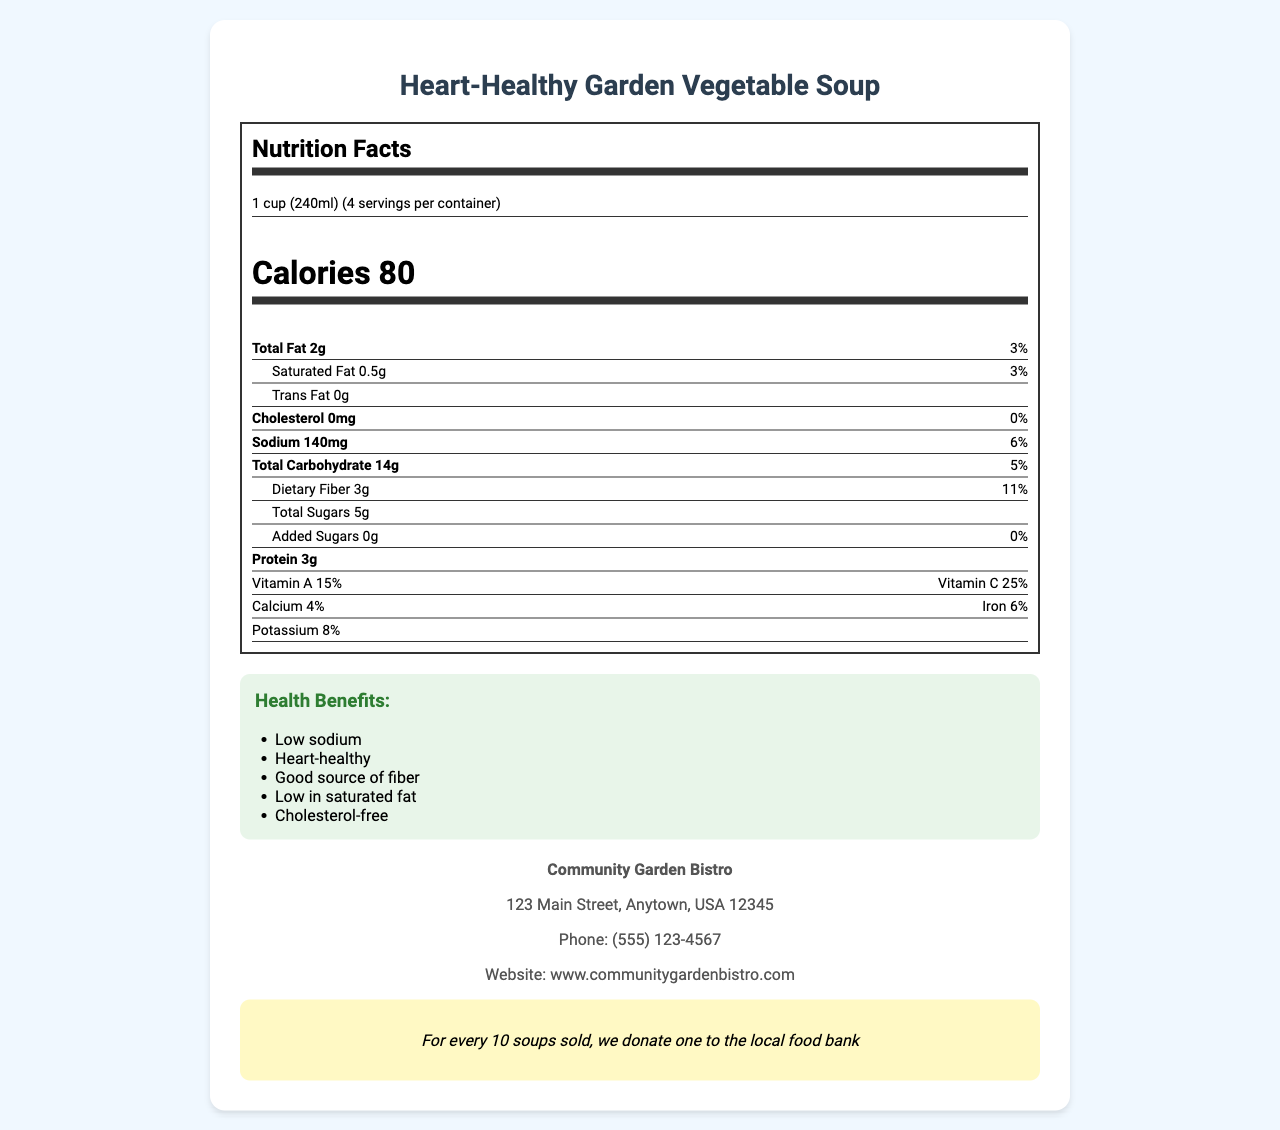What is the serving size for the Heart-Healthy Garden Vegetable Soup? The serving size is listed as "1 cup (240ml)" in the document.
Answer: 1 cup (240ml) How many calories are there per serving? The document states that there are 80 calories per serving.
Answer: 80 What percentage of the daily value of sodium does one serving contain? The sodium content per serving is listed as 6% of the daily value.
Answer: 6% List three main ingredients found in the Heart-Healthy Garden Vegetable Soup. The document lists "Vegetable broth," "Tomatoes," and "Carrots" among the ingredients.
Answer: Vegetable broth, Tomatoes, Carrots What is the preparation method mentioned for the soup? The preparation method stated in the document is "Slow-cooked to preserve nutrients."
Answer: Slow-cooked to preserve nutrients What certification does the soup have for its heart-health benefits? A. USDA Organic B. Non-GMO Project Verified C. American Heart Association Certified The document mentions that the soup is "American Heart Association Certified."
Answer: C Which of the following is a health claim made about the soup? I. Low sodium II. High protein III. Low in saturated fat The health claims listed in the document include "Low sodium" and "Low in saturated fat."
Answer: I and III Does the soup contain any allergens? The document states that there are "None" listed under allergens.
Answer: No Summarize the main idea of the document. The document provides comprehensive information on the soup's nutritional value, ingredients, certifications, and its contribution to the community, emphasizing its heart-healthy and low-sodium benefits.
Answer: The document describes the Heart-Healthy Garden Vegetable Soup, highlighting its nutrition facts, health benefits, preparation method, and community initiative. Is the Heart-Healthy Garden Vegetable Soup suitable for someone who is monitoring their sodium intake? The document states that the soup is "Low sodium," making it suitable for someone monitoring their sodium intake.
Answer: Yes Where are the ingredients for the soup sourced from? The document only mentions that ingredients are sourced from local farms "when possible," but does not specify where each ingredient is sourced from.
Answer: Cannot be determined How much dietary fiber does each serving provide? The document lists the dietary fiber content as "3g" and "11%" of the daily value per serving.
Answer: 3g (11% Daily Value) What is the address of the restaurant that offers this soup? The restaurant address is listed in the document.
Answer: 123 Main Street, Anytown, USA 12345 What is the soup's cholesterol content per serving? The document states that the soup contains 0mg of cholesterol per serving.
Answer: 0mg 